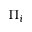Convert formula to latex. <formula><loc_0><loc_0><loc_500><loc_500>\Pi _ { i }</formula> 